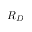Convert formula to latex. <formula><loc_0><loc_0><loc_500><loc_500>R _ { D }</formula> 